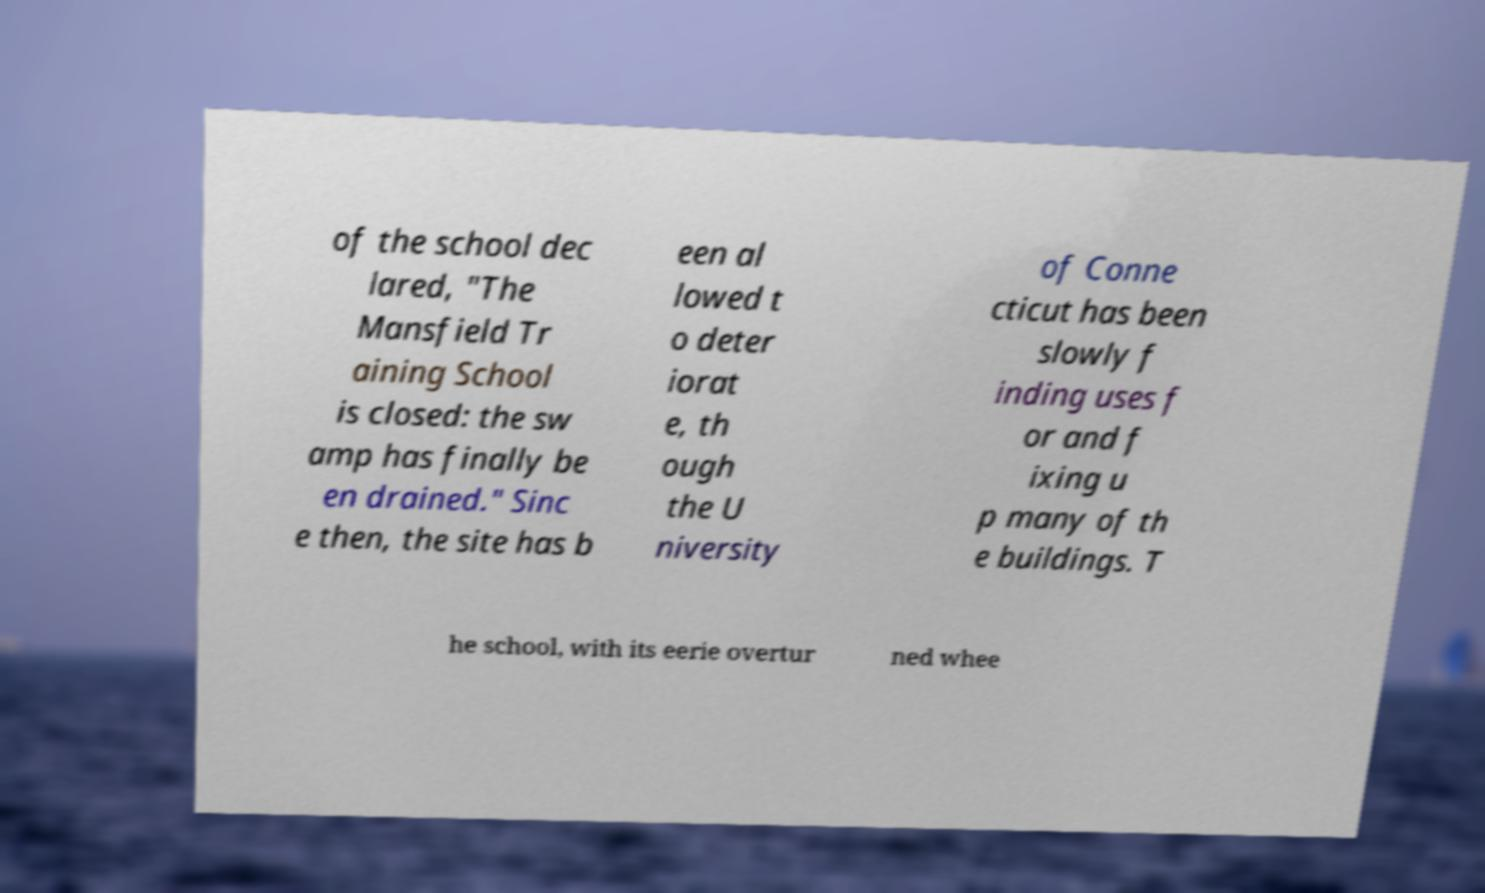I need the written content from this picture converted into text. Can you do that? of the school dec lared, "The Mansfield Tr aining School is closed: the sw amp has finally be en drained." Sinc e then, the site has b een al lowed t o deter iorat e, th ough the U niversity of Conne cticut has been slowly f inding uses f or and f ixing u p many of th e buildings. T he school, with its eerie overtur ned whee 